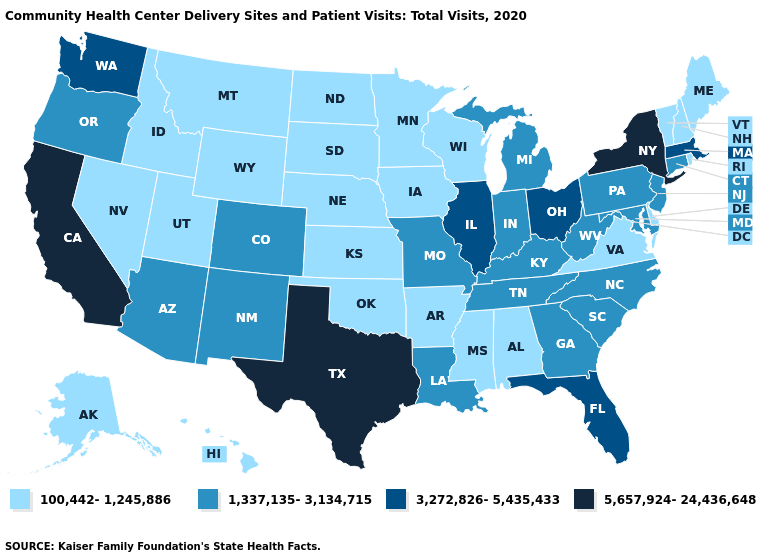Does Tennessee have a higher value than Washington?
Give a very brief answer. No. Does Indiana have the same value as Alabama?
Concise answer only. No. What is the highest value in states that border Maine?
Answer briefly. 100,442-1,245,886. Does West Virginia have the highest value in the USA?
Write a very short answer. No. Does Delaware have a lower value than Rhode Island?
Quick response, please. No. Name the states that have a value in the range 100,442-1,245,886?
Concise answer only. Alabama, Alaska, Arkansas, Delaware, Hawaii, Idaho, Iowa, Kansas, Maine, Minnesota, Mississippi, Montana, Nebraska, Nevada, New Hampshire, North Dakota, Oklahoma, Rhode Island, South Dakota, Utah, Vermont, Virginia, Wisconsin, Wyoming. Name the states that have a value in the range 1,337,135-3,134,715?
Quick response, please. Arizona, Colorado, Connecticut, Georgia, Indiana, Kentucky, Louisiana, Maryland, Michigan, Missouri, New Jersey, New Mexico, North Carolina, Oregon, Pennsylvania, South Carolina, Tennessee, West Virginia. Does West Virginia have a higher value than Iowa?
Give a very brief answer. Yes. What is the value of Alabama?
Give a very brief answer. 100,442-1,245,886. Does Nevada have the same value as West Virginia?
Write a very short answer. No. Name the states that have a value in the range 100,442-1,245,886?
Quick response, please. Alabama, Alaska, Arkansas, Delaware, Hawaii, Idaho, Iowa, Kansas, Maine, Minnesota, Mississippi, Montana, Nebraska, Nevada, New Hampshire, North Dakota, Oklahoma, Rhode Island, South Dakota, Utah, Vermont, Virginia, Wisconsin, Wyoming. What is the value of New Jersey?
Keep it brief. 1,337,135-3,134,715. Is the legend a continuous bar?
Keep it brief. No. Name the states that have a value in the range 100,442-1,245,886?
Short answer required. Alabama, Alaska, Arkansas, Delaware, Hawaii, Idaho, Iowa, Kansas, Maine, Minnesota, Mississippi, Montana, Nebraska, Nevada, New Hampshire, North Dakota, Oklahoma, Rhode Island, South Dakota, Utah, Vermont, Virginia, Wisconsin, Wyoming. Does Delaware have the lowest value in the USA?
Quick response, please. Yes. 